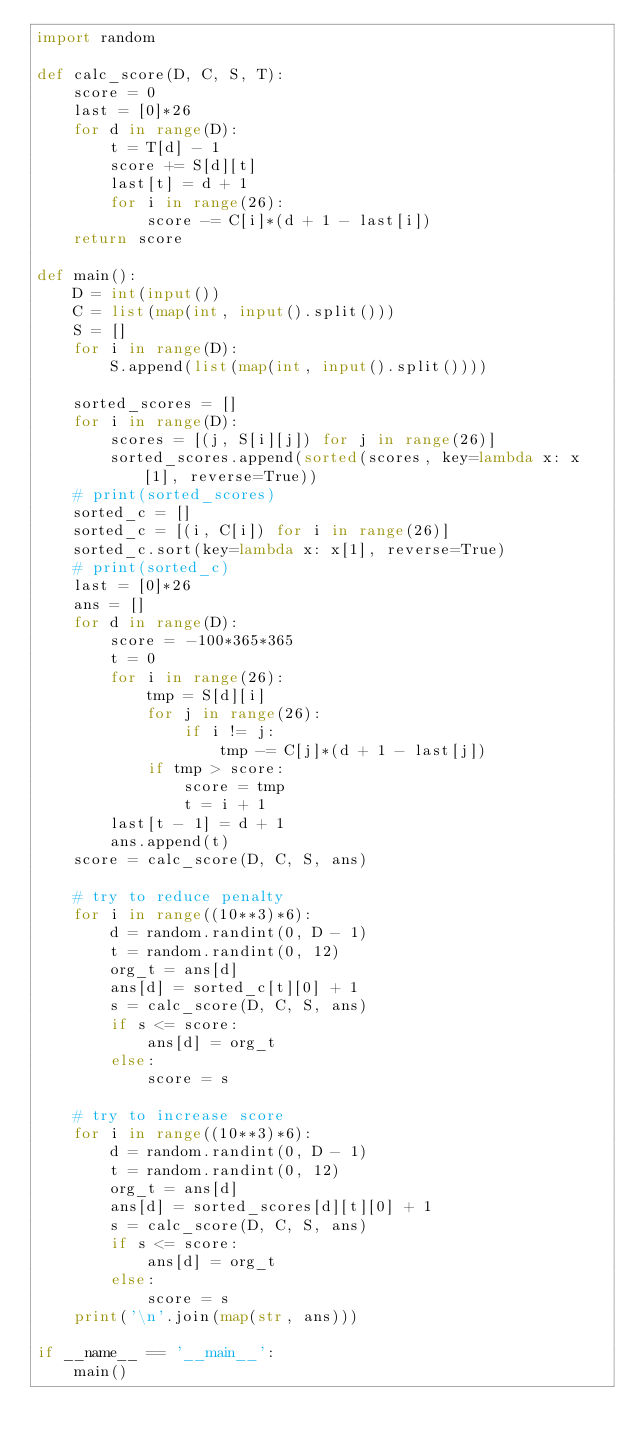Convert code to text. <code><loc_0><loc_0><loc_500><loc_500><_Python_>import random

def calc_score(D, C, S, T):
    score = 0
    last = [0]*26
    for d in range(D):
        t = T[d] - 1
        score += S[d][t]
        last[t] = d + 1
        for i in range(26):
            score -= C[i]*(d + 1 - last[i])
    return score

def main():
    D = int(input())
    C = list(map(int, input().split()))
    S = []
    for i in range(D):
        S.append(list(map(int, input().split())))

    sorted_scores = []
    for i in range(D):
        scores = [(j, S[i][j]) for j in range(26)]
        sorted_scores.append(sorted(scores, key=lambda x: x[1], reverse=True))
    # print(sorted_scores)
    sorted_c = []
    sorted_c = [(i, C[i]) for i in range(26)]
    sorted_c.sort(key=lambda x: x[1], reverse=True)
    # print(sorted_c)
    last = [0]*26
    ans = []
    for d in range(D):
        score = -100*365*365
        t = 0
        for i in range(26):
            tmp = S[d][i]
            for j in range(26):
                if i != j:
                    tmp -= C[j]*(d + 1 - last[j])
            if tmp > score:
                score = tmp
                t = i + 1
        last[t - 1] = d + 1
        ans.append(t)
    score = calc_score(D, C, S, ans)

    # try to reduce penalty
    for i in range((10**3)*6):
        d = random.randint(0, D - 1)
        t = random.randint(0, 12)
        org_t = ans[d]
        ans[d] = sorted_c[t][0] + 1
        s = calc_score(D, C, S, ans)
        if s <= score:
            ans[d] = org_t
        else:
            score = s

    # try to increase score
    for i in range((10**3)*6):
        d = random.randint(0, D - 1)
        t = random.randint(0, 12)
        org_t = ans[d]
        ans[d] = sorted_scores[d][t][0] + 1
        s = calc_score(D, C, S, ans)
        if s <= score:
            ans[d] = org_t
        else:
            score = s
    print('\n'.join(map(str, ans)))

if __name__ == '__main__':
    main()
</code> 